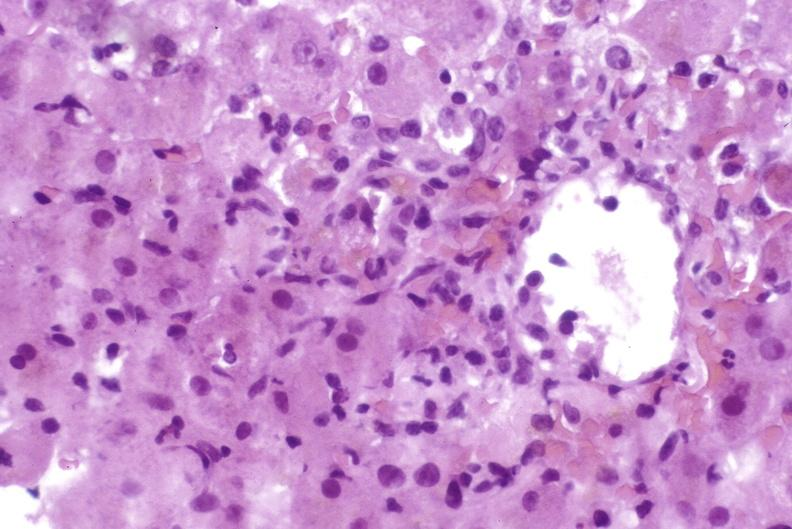s liver present?
Answer the question using a single word or phrase. Yes 